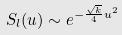<formula> <loc_0><loc_0><loc_500><loc_500>S _ { l } ( u ) \sim e ^ { - \frac { \sqrt { k } } { 4 } u ^ { 2 } }</formula> 